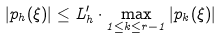Convert formula to latex. <formula><loc_0><loc_0><loc_500><loc_500>\left | p _ { h } ( \xi ) \right | \leq L ^ { \prime } _ { h } \cdot \max _ { 1 \leq k \leq r - 1 } \left | p _ { k } ( \xi ) \right |</formula> 